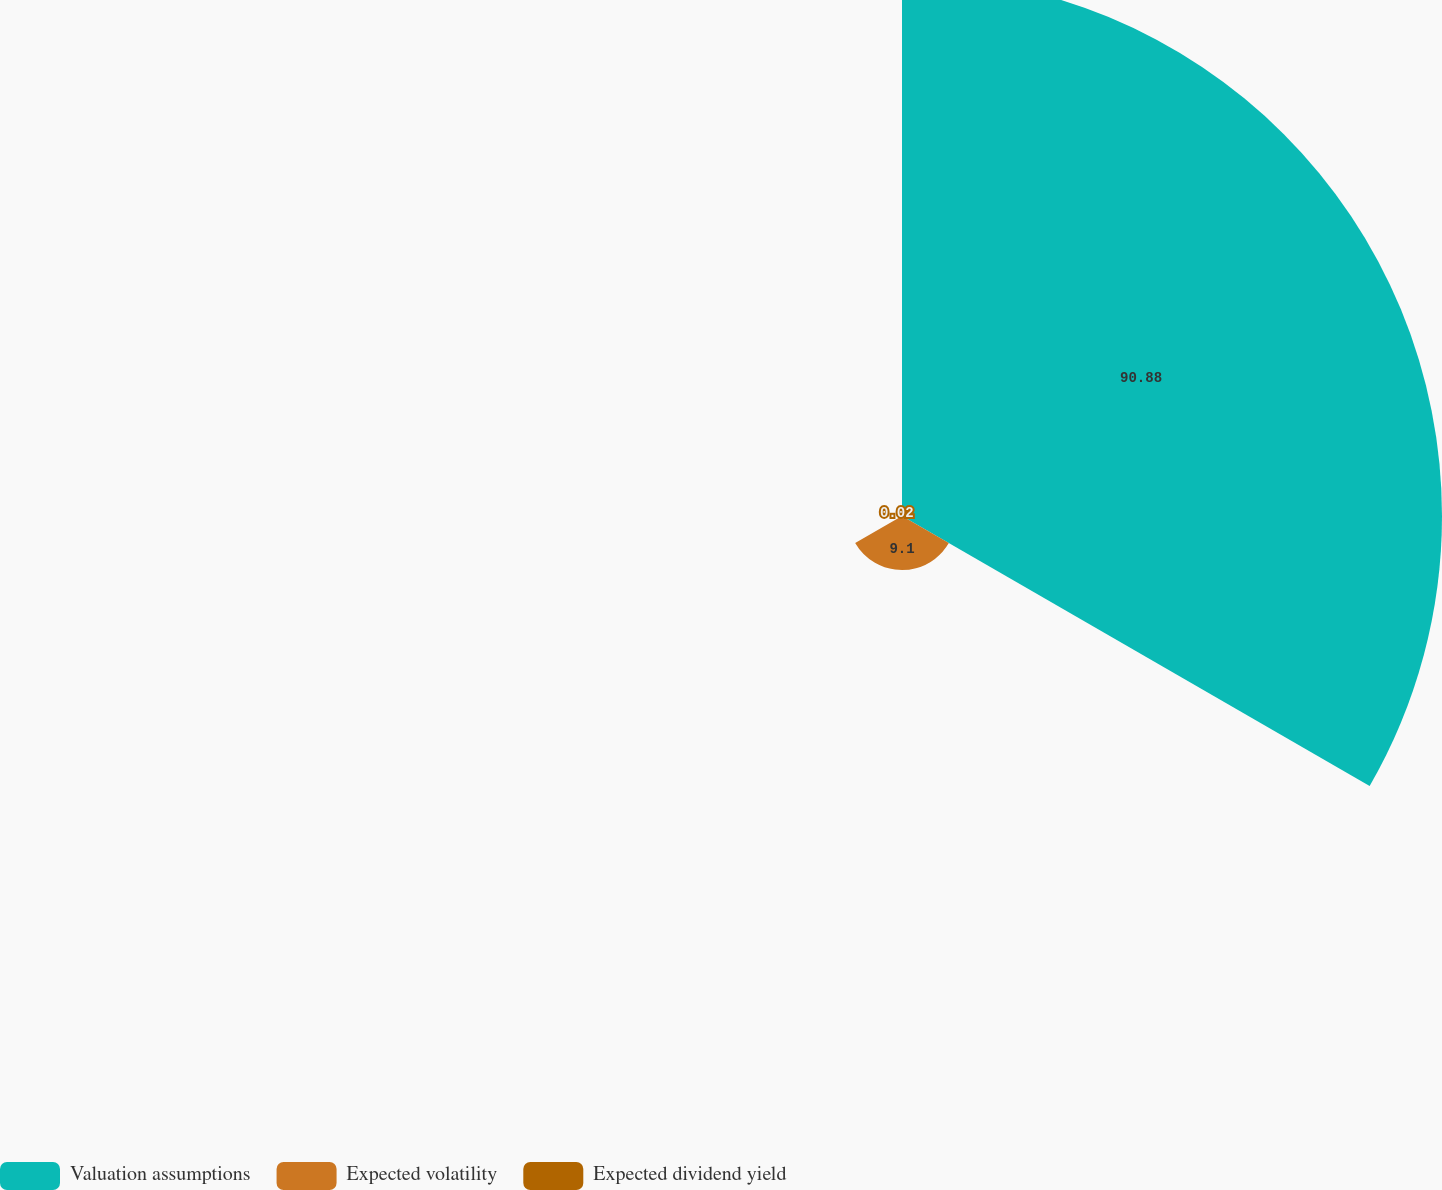<chart> <loc_0><loc_0><loc_500><loc_500><pie_chart><fcel>Valuation assumptions<fcel>Expected volatility<fcel>Expected dividend yield<nl><fcel>90.88%<fcel>9.1%<fcel>0.02%<nl></chart> 